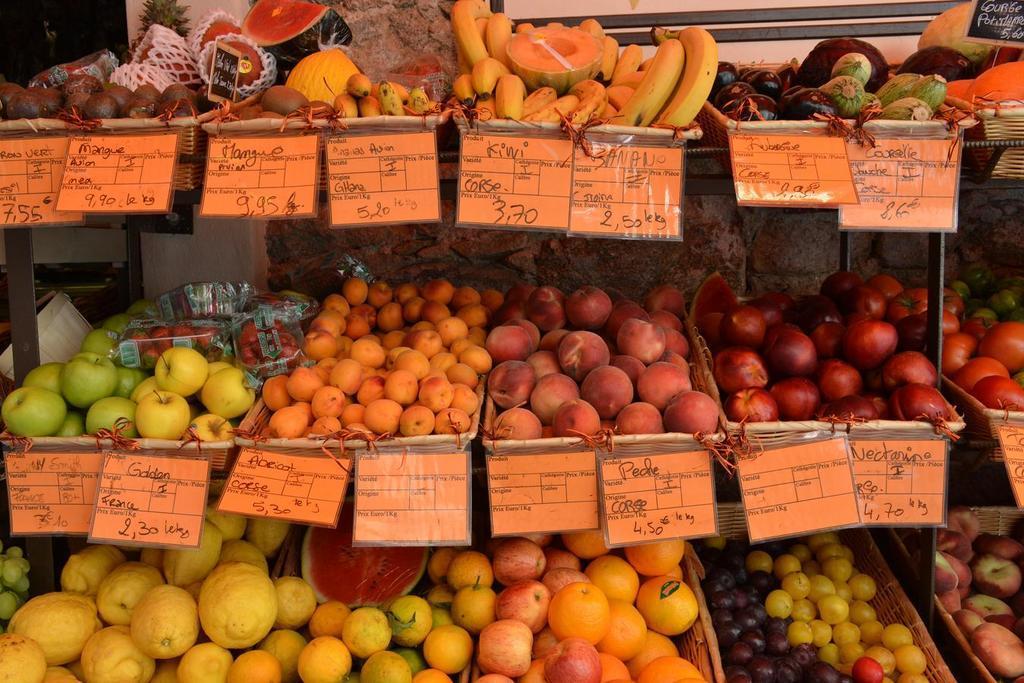How would you summarize this image in a sentence or two? In this image we can see fruits arranged in baskets. There are boards with some text on it. 